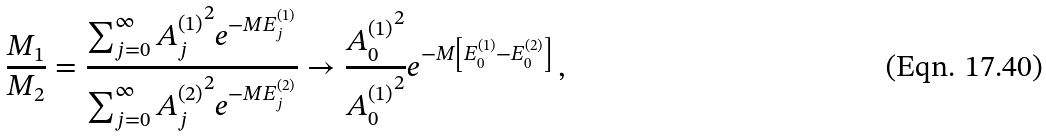Convert formula to latex. <formula><loc_0><loc_0><loc_500><loc_500>\frac { M _ { 1 } } { M _ { 2 } } = \frac { \sum _ { j = 0 } ^ { \infty } { A _ { j } ^ { ( 1 ) } } ^ { 2 } e ^ { - M E _ { j } ^ { ( 1 ) } } } { \sum _ { j = 0 } ^ { \infty } { A _ { j } ^ { ( 2 ) } } ^ { 2 } e ^ { - M E _ { j } ^ { ( 2 ) } } } \rightarrow \frac { { A _ { 0 } ^ { ( 1 ) } } ^ { 2 } } { { A _ { 0 } ^ { ( 1 ) } } ^ { 2 } } e ^ { - M \left [ E _ { 0 } ^ { ( 1 ) } - E _ { 0 } ^ { ( 2 ) } \right ] } \, ,</formula> 